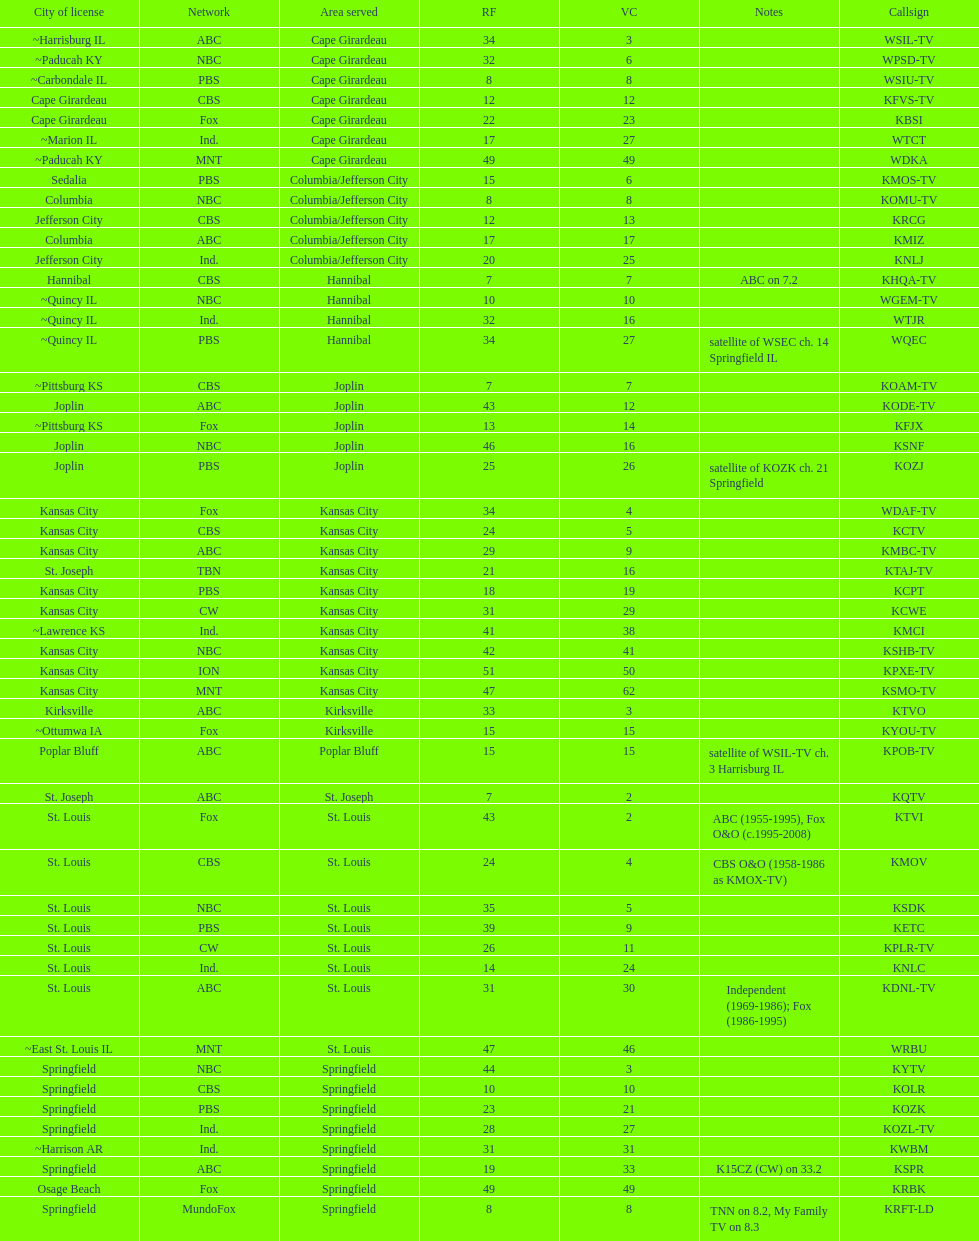Give me the full table as a dictionary. {'header': ['City of license', 'Network', 'Area served', 'RF', 'VC', 'Notes', 'Callsign'], 'rows': [['~Harrisburg IL', 'ABC', 'Cape Girardeau', '34', '3', '', 'WSIL-TV'], ['~Paducah KY', 'NBC', 'Cape Girardeau', '32', '6', '', 'WPSD-TV'], ['~Carbondale IL', 'PBS', 'Cape Girardeau', '8', '8', '', 'WSIU-TV'], ['Cape Girardeau', 'CBS', 'Cape Girardeau', '12', '12', '', 'KFVS-TV'], ['Cape Girardeau', 'Fox', 'Cape Girardeau', '22', '23', '', 'KBSI'], ['~Marion IL', 'Ind.', 'Cape Girardeau', '17', '27', '', 'WTCT'], ['~Paducah KY', 'MNT', 'Cape Girardeau', '49', '49', '', 'WDKA'], ['Sedalia', 'PBS', 'Columbia/Jefferson City', '15', '6', '', 'KMOS-TV'], ['Columbia', 'NBC', 'Columbia/Jefferson City', '8', '8', '', 'KOMU-TV'], ['Jefferson City', 'CBS', 'Columbia/Jefferson City', '12', '13', '', 'KRCG'], ['Columbia', 'ABC', 'Columbia/Jefferson City', '17', '17', '', 'KMIZ'], ['Jefferson City', 'Ind.', 'Columbia/Jefferson City', '20', '25', '', 'KNLJ'], ['Hannibal', 'CBS', 'Hannibal', '7', '7', 'ABC on 7.2', 'KHQA-TV'], ['~Quincy IL', 'NBC', 'Hannibal', '10', '10', '', 'WGEM-TV'], ['~Quincy IL', 'Ind.', 'Hannibal', '32', '16', '', 'WTJR'], ['~Quincy IL', 'PBS', 'Hannibal', '34', '27', 'satellite of WSEC ch. 14 Springfield IL', 'WQEC'], ['~Pittsburg KS', 'CBS', 'Joplin', '7', '7', '', 'KOAM-TV'], ['Joplin', 'ABC', 'Joplin', '43', '12', '', 'KODE-TV'], ['~Pittsburg KS', 'Fox', 'Joplin', '13', '14', '', 'KFJX'], ['Joplin', 'NBC', 'Joplin', '46', '16', '', 'KSNF'], ['Joplin', 'PBS', 'Joplin', '25', '26', 'satellite of KOZK ch. 21 Springfield', 'KOZJ'], ['Kansas City', 'Fox', 'Kansas City', '34', '4', '', 'WDAF-TV'], ['Kansas City', 'CBS', 'Kansas City', '24', '5', '', 'KCTV'], ['Kansas City', 'ABC', 'Kansas City', '29', '9', '', 'KMBC-TV'], ['St. Joseph', 'TBN', 'Kansas City', '21', '16', '', 'KTAJ-TV'], ['Kansas City', 'PBS', 'Kansas City', '18', '19', '', 'KCPT'], ['Kansas City', 'CW', 'Kansas City', '31', '29', '', 'KCWE'], ['~Lawrence KS', 'Ind.', 'Kansas City', '41', '38', '', 'KMCI'], ['Kansas City', 'NBC', 'Kansas City', '42', '41', '', 'KSHB-TV'], ['Kansas City', 'ION', 'Kansas City', '51', '50', '', 'KPXE-TV'], ['Kansas City', 'MNT', 'Kansas City', '47', '62', '', 'KSMO-TV'], ['Kirksville', 'ABC', 'Kirksville', '33', '3', '', 'KTVO'], ['~Ottumwa IA', 'Fox', 'Kirksville', '15', '15', '', 'KYOU-TV'], ['Poplar Bluff', 'ABC', 'Poplar Bluff', '15', '15', 'satellite of WSIL-TV ch. 3 Harrisburg IL', 'KPOB-TV'], ['St. Joseph', 'ABC', 'St. Joseph', '7', '2', '', 'KQTV'], ['St. Louis', 'Fox', 'St. Louis', '43', '2', 'ABC (1955-1995), Fox O&O (c.1995-2008)', 'KTVI'], ['St. Louis', 'CBS', 'St. Louis', '24', '4', 'CBS O&O (1958-1986 as KMOX-TV)', 'KMOV'], ['St. Louis', 'NBC', 'St. Louis', '35', '5', '', 'KSDK'], ['St. Louis', 'PBS', 'St. Louis', '39', '9', '', 'KETC'], ['St. Louis', 'CW', 'St. Louis', '26', '11', '', 'KPLR-TV'], ['St. Louis', 'Ind.', 'St. Louis', '14', '24', '', 'KNLC'], ['St. Louis', 'ABC', 'St. Louis', '31', '30', 'Independent (1969-1986); Fox (1986-1995)', 'KDNL-TV'], ['~East St. Louis IL', 'MNT', 'St. Louis', '47', '46', '', 'WRBU'], ['Springfield', 'NBC', 'Springfield', '44', '3', '', 'KYTV'], ['Springfield', 'CBS', 'Springfield', '10', '10', '', 'KOLR'], ['Springfield', 'PBS', 'Springfield', '23', '21', '', 'KOZK'], ['Springfield', 'Ind.', 'Springfield', '28', '27', '', 'KOZL-TV'], ['~Harrison AR', 'Ind.', 'Springfield', '31', '31', '', 'KWBM'], ['Springfield', 'ABC', 'Springfield', '19', '33', 'K15CZ (CW) on 33.2', 'KSPR'], ['Osage Beach', 'Fox', 'Springfield', '49', '49', '', 'KRBK'], ['Springfield', 'MundoFox', 'Springfield', '8', '8', 'TNN on 8.2, My Family TV on 8.3', 'KRFT-LD']]} Kode-tv and wsil-tv both are a part of which network? ABC. 